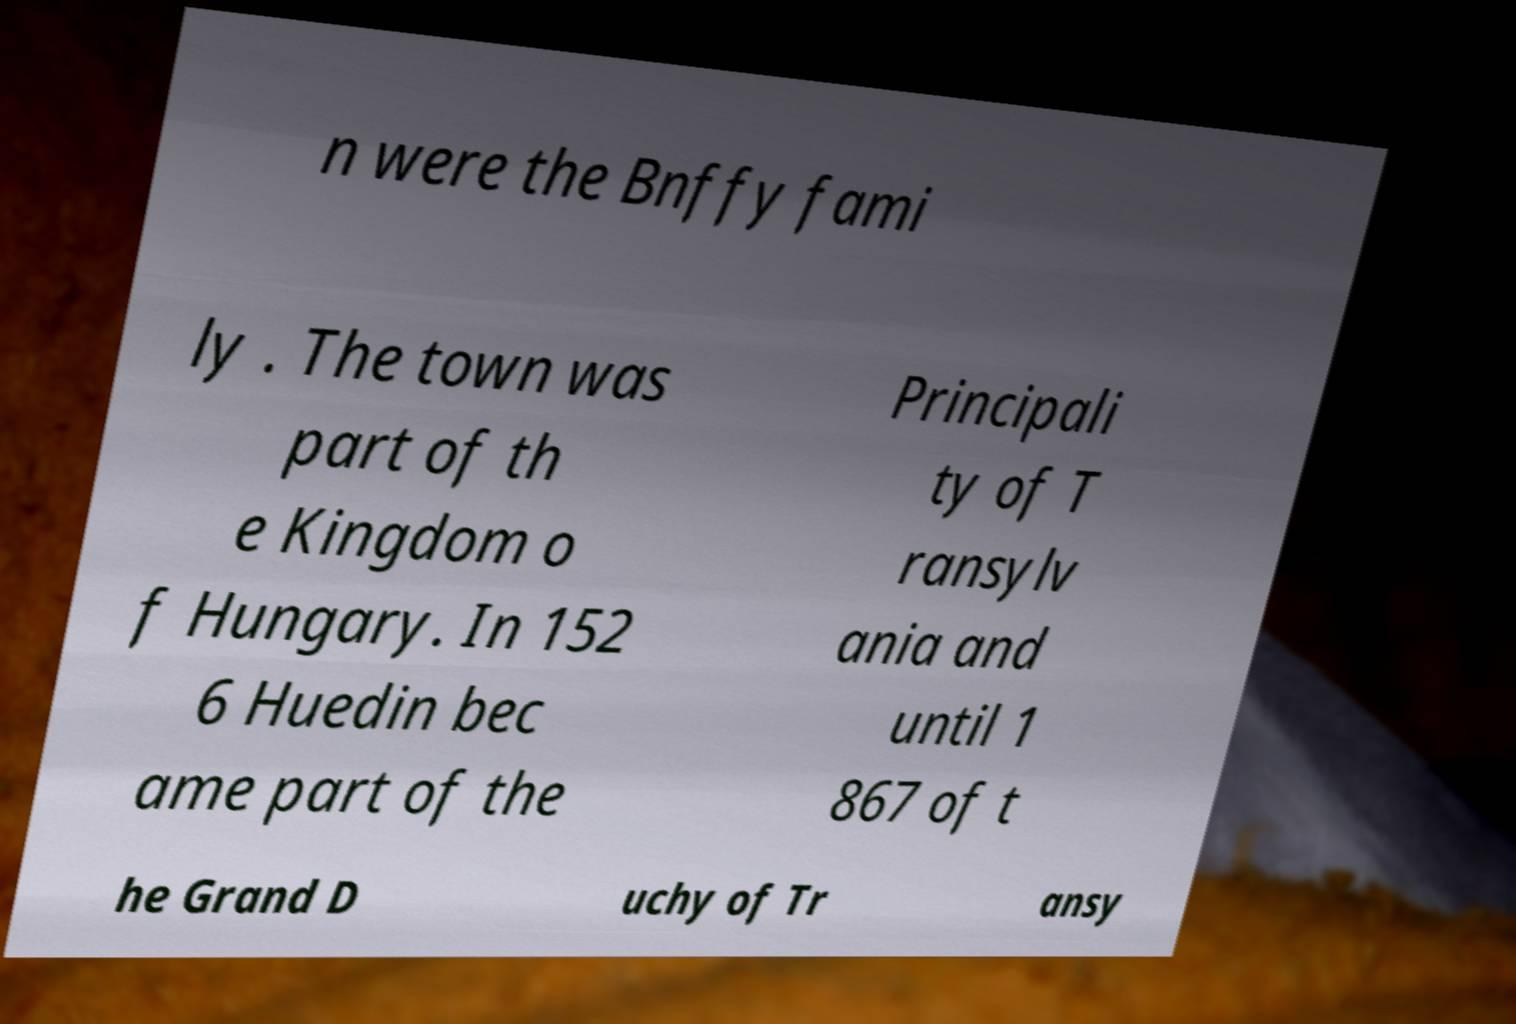Could you extract and type out the text from this image? n were the Bnffy fami ly . The town was part of th e Kingdom o f Hungary. In 152 6 Huedin bec ame part of the Principali ty of T ransylv ania and until 1 867 of t he Grand D uchy of Tr ansy 